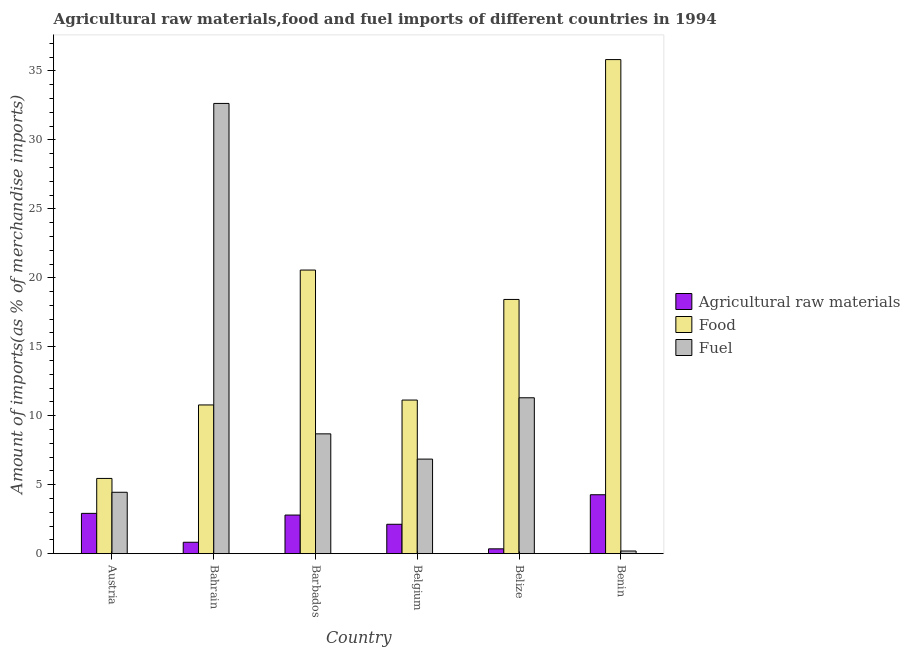How many different coloured bars are there?
Your response must be concise. 3. Are the number of bars on each tick of the X-axis equal?
Offer a very short reply. Yes. How many bars are there on the 1st tick from the left?
Give a very brief answer. 3. In how many cases, is the number of bars for a given country not equal to the number of legend labels?
Provide a short and direct response. 0. What is the percentage of raw materials imports in Austria?
Provide a short and direct response. 2.92. Across all countries, what is the maximum percentage of fuel imports?
Offer a terse response. 32.64. Across all countries, what is the minimum percentage of fuel imports?
Offer a terse response. 0.19. In which country was the percentage of fuel imports maximum?
Make the answer very short. Bahrain. What is the total percentage of raw materials imports in the graph?
Keep it short and to the point. 13.29. What is the difference between the percentage of fuel imports in Barbados and that in Belize?
Make the answer very short. -2.62. What is the difference between the percentage of raw materials imports in Belize and the percentage of food imports in Barbados?
Offer a very short reply. -20.21. What is the average percentage of fuel imports per country?
Offer a terse response. 10.69. What is the difference between the percentage of raw materials imports and percentage of food imports in Belgium?
Your answer should be compact. -9.01. What is the ratio of the percentage of fuel imports in Belgium to that in Benin?
Offer a terse response. 35.95. Is the percentage of food imports in Barbados less than that in Belize?
Offer a terse response. No. Is the difference between the percentage of fuel imports in Bahrain and Belgium greater than the difference between the percentage of food imports in Bahrain and Belgium?
Ensure brevity in your answer.  Yes. What is the difference between the highest and the second highest percentage of raw materials imports?
Offer a very short reply. 1.35. What is the difference between the highest and the lowest percentage of fuel imports?
Make the answer very short. 32.45. In how many countries, is the percentage of fuel imports greater than the average percentage of fuel imports taken over all countries?
Provide a succinct answer. 2. Is the sum of the percentage of fuel imports in Barbados and Belgium greater than the maximum percentage of raw materials imports across all countries?
Your answer should be very brief. Yes. What does the 3rd bar from the left in Austria represents?
Offer a very short reply. Fuel. What does the 3rd bar from the right in Benin represents?
Your response must be concise. Agricultural raw materials. Is it the case that in every country, the sum of the percentage of raw materials imports and percentage of food imports is greater than the percentage of fuel imports?
Make the answer very short. No. What is the difference between two consecutive major ticks on the Y-axis?
Ensure brevity in your answer.  5. Are the values on the major ticks of Y-axis written in scientific E-notation?
Offer a very short reply. No. How many legend labels are there?
Give a very brief answer. 3. How are the legend labels stacked?
Provide a succinct answer. Vertical. What is the title of the graph?
Provide a succinct answer. Agricultural raw materials,food and fuel imports of different countries in 1994. What is the label or title of the X-axis?
Make the answer very short. Country. What is the label or title of the Y-axis?
Provide a short and direct response. Amount of imports(as % of merchandise imports). What is the Amount of imports(as % of merchandise imports) of Agricultural raw materials in Austria?
Provide a short and direct response. 2.92. What is the Amount of imports(as % of merchandise imports) of Food in Austria?
Your answer should be very brief. 5.45. What is the Amount of imports(as % of merchandise imports) of Fuel in Austria?
Your answer should be very brief. 4.45. What is the Amount of imports(as % of merchandise imports) in Agricultural raw materials in Bahrain?
Your answer should be very brief. 0.83. What is the Amount of imports(as % of merchandise imports) in Food in Bahrain?
Your answer should be compact. 10.78. What is the Amount of imports(as % of merchandise imports) of Fuel in Bahrain?
Your answer should be compact. 32.64. What is the Amount of imports(as % of merchandise imports) in Agricultural raw materials in Barbados?
Make the answer very short. 2.8. What is the Amount of imports(as % of merchandise imports) of Food in Barbados?
Keep it short and to the point. 20.56. What is the Amount of imports(as % of merchandise imports) of Fuel in Barbados?
Offer a terse response. 8.69. What is the Amount of imports(as % of merchandise imports) in Agricultural raw materials in Belgium?
Offer a very short reply. 2.13. What is the Amount of imports(as % of merchandise imports) in Food in Belgium?
Offer a very short reply. 11.14. What is the Amount of imports(as % of merchandise imports) of Fuel in Belgium?
Your answer should be very brief. 6.85. What is the Amount of imports(as % of merchandise imports) in Agricultural raw materials in Belize?
Make the answer very short. 0.35. What is the Amount of imports(as % of merchandise imports) in Food in Belize?
Ensure brevity in your answer.  18.43. What is the Amount of imports(as % of merchandise imports) in Fuel in Belize?
Your answer should be compact. 11.3. What is the Amount of imports(as % of merchandise imports) of Agricultural raw materials in Benin?
Your response must be concise. 4.27. What is the Amount of imports(as % of merchandise imports) of Food in Benin?
Give a very brief answer. 35.82. What is the Amount of imports(as % of merchandise imports) in Fuel in Benin?
Offer a terse response. 0.19. Across all countries, what is the maximum Amount of imports(as % of merchandise imports) in Agricultural raw materials?
Offer a very short reply. 4.27. Across all countries, what is the maximum Amount of imports(as % of merchandise imports) of Food?
Your response must be concise. 35.82. Across all countries, what is the maximum Amount of imports(as % of merchandise imports) of Fuel?
Your answer should be compact. 32.64. Across all countries, what is the minimum Amount of imports(as % of merchandise imports) in Agricultural raw materials?
Give a very brief answer. 0.35. Across all countries, what is the minimum Amount of imports(as % of merchandise imports) of Food?
Provide a succinct answer. 5.45. Across all countries, what is the minimum Amount of imports(as % of merchandise imports) of Fuel?
Your answer should be very brief. 0.19. What is the total Amount of imports(as % of merchandise imports) of Agricultural raw materials in the graph?
Your answer should be compact. 13.29. What is the total Amount of imports(as % of merchandise imports) in Food in the graph?
Offer a very short reply. 102.19. What is the total Amount of imports(as % of merchandise imports) in Fuel in the graph?
Ensure brevity in your answer.  64.12. What is the difference between the Amount of imports(as % of merchandise imports) of Agricultural raw materials in Austria and that in Bahrain?
Your answer should be compact. 2.09. What is the difference between the Amount of imports(as % of merchandise imports) in Food in Austria and that in Bahrain?
Your response must be concise. -5.33. What is the difference between the Amount of imports(as % of merchandise imports) of Fuel in Austria and that in Bahrain?
Keep it short and to the point. -28.19. What is the difference between the Amount of imports(as % of merchandise imports) of Agricultural raw materials in Austria and that in Barbados?
Make the answer very short. 0.12. What is the difference between the Amount of imports(as % of merchandise imports) in Food in Austria and that in Barbados?
Ensure brevity in your answer.  -15.11. What is the difference between the Amount of imports(as % of merchandise imports) of Fuel in Austria and that in Barbados?
Offer a terse response. -4.24. What is the difference between the Amount of imports(as % of merchandise imports) of Agricultural raw materials in Austria and that in Belgium?
Offer a very short reply. 0.79. What is the difference between the Amount of imports(as % of merchandise imports) of Food in Austria and that in Belgium?
Provide a short and direct response. -5.68. What is the difference between the Amount of imports(as % of merchandise imports) of Fuel in Austria and that in Belgium?
Ensure brevity in your answer.  -2.4. What is the difference between the Amount of imports(as % of merchandise imports) in Agricultural raw materials in Austria and that in Belize?
Keep it short and to the point. 2.57. What is the difference between the Amount of imports(as % of merchandise imports) in Food in Austria and that in Belize?
Make the answer very short. -12.98. What is the difference between the Amount of imports(as % of merchandise imports) in Fuel in Austria and that in Belize?
Offer a very short reply. -6.85. What is the difference between the Amount of imports(as % of merchandise imports) in Agricultural raw materials in Austria and that in Benin?
Your response must be concise. -1.35. What is the difference between the Amount of imports(as % of merchandise imports) of Food in Austria and that in Benin?
Provide a short and direct response. -30.37. What is the difference between the Amount of imports(as % of merchandise imports) in Fuel in Austria and that in Benin?
Provide a short and direct response. 4.26. What is the difference between the Amount of imports(as % of merchandise imports) in Agricultural raw materials in Bahrain and that in Barbados?
Provide a short and direct response. -1.97. What is the difference between the Amount of imports(as % of merchandise imports) in Food in Bahrain and that in Barbados?
Give a very brief answer. -9.78. What is the difference between the Amount of imports(as % of merchandise imports) in Fuel in Bahrain and that in Barbados?
Provide a short and direct response. 23.96. What is the difference between the Amount of imports(as % of merchandise imports) in Agricultural raw materials in Bahrain and that in Belgium?
Keep it short and to the point. -1.3. What is the difference between the Amount of imports(as % of merchandise imports) in Food in Bahrain and that in Belgium?
Ensure brevity in your answer.  -0.35. What is the difference between the Amount of imports(as % of merchandise imports) in Fuel in Bahrain and that in Belgium?
Keep it short and to the point. 25.79. What is the difference between the Amount of imports(as % of merchandise imports) of Agricultural raw materials in Bahrain and that in Belize?
Your response must be concise. 0.48. What is the difference between the Amount of imports(as % of merchandise imports) in Food in Bahrain and that in Belize?
Make the answer very short. -7.65. What is the difference between the Amount of imports(as % of merchandise imports) of Fuel in Bahrain and that in Belize?
Make the answer very short. 21.34. What is the difference between the Amount of imports(as % of merchandise imports) of Agricultural raw materials in Bahrain and that in Benin?
Your answer should be compact. -3.45. What is the difference between the Amount of imports(as % of merchandise imports) in Food in Bahrain and that in Benin?
Your answer should be compact. -25.04. What is the difference between the Amount of imports(as % of merchandise imports) of Fuel in Bahrain and that in Benin?
Your response must be concise. 32.45. What is the difference between the Amount of imports(as % of merchandise imports) in Agricultural raw materials in Barbados and that in Belgium?
Offer a terse response. 0.67. What is the difference between the Amount of imports(as % of merchandise imports) of Food in Barbados and that in Belgium?
Offer a terse response. 9.43. What is the difference between the Amount of imports(as % of merchandise imports) in Fuel in Barbados and that in Belgium?
Give a very brief answer. 1.83. What is the difference between the Amount of imports(as % of merchandise imports) of Agricultural raw materials in Barbados and that in Belize?
Your answer should be compact. 2.45. What is the difference between the Amount of imports(as % of merchandise imports) of Food in Barbados and that in Belize?
Offer a very short reply. 2.13. What is the difference between the Amount of imports(as % of merchandise imports) of Fuel in Barbados and that in Belize?
Keep it short and to the point. -2.62. What is the difference between the Amount of imports(as % of merchandise imports) in Agricultural raw materials in Barbados and that in Benin?
Offer a very short reply. -1.47. What is the difference between the Amount of imports(as % of merchandise imports) of Food in Barbados and that in Benin?
Provide a succinct answer. -15.26. What is the difference between the Amount of imports(as % of merchandise imports) of Fuel in Barbados and that in Benin?
Make the answer very short. 8.5. What is the difference between the Amount of imports(as % of merchandise imports) in Agricultural raw materials in Belgium and that in Belize?
Keep it short and to the point. 1.78. What is the difference between the Amount of imports(as % of merchandise imports) of Food in Belgium and that in Belize?
Your response must be concise. -7.29. What is the difference between the Amount of imports(as % of merchandise imports) of Fuel in Belgium and that in Belize?
Give a very brief answer. -4.45. What is the difference between the Amount of imports(as % of merchandise imports) in Agricultural raw materials in Belgium and that in Benin?
Your answer should be very brief. -2.14. What is the difference between the Amount of imports(as % of merchandise imports) in Food in Belgium and that in Benin?
Offer a very short reply. -24.69. What is the difference between the Amount of imports(as % of merchandise imports) in Fuel in Belgium and that in Benin?
Your response must be concise. 6.66. What is the difference between the Amount of imports(as % of merchandise imports) of Agricultural raw materials in Belize and that in Benin?
Provide a short and direct response. -3.92. What is the difference between the Amount of imports(as % of merchandise imports) in Food in Belize and that in Benin?
Provide a succinct answer. -17.39. What is the difference between the Amount of imports(as % of merchandise imports) in Fuel in Belize and that in Benin?
Provide a short and direct response. 11.11. What is the difference between the Amount of imports(as % of merchandise imports) in Agricultural raw materials in Austria and the Amount of imports(as % of merchandise imports) in Food in Bahrain?
Offer a very short reply. -7.86. What is the difference between the Amount of imports(as % of merchandise imports) of Agricultural raw materials in Austria and the Amount of imports(as % of merchandise imports) of Fuel in Bahrain?
Make the answer very short. -29.72. What is the difference between the Amount of imports(as % of merchandise imports) of Food in Austria and the Amount of imports(as % of merchandise imports) of Fuel in Bahrain?
Provide a short and direct response. -27.19. What is the difference between the Amount of imports(as % of merchandise imports) in Agricultural raw materials in Austria and the Amount of imports(as % of merchandise imports) in Food in Barbados?
Your answer should be compact. -17.64. What is the difference between the Amount of imports(as % of merchandise imports) of Agricultural raw materials in Austria and the Amount of imports(as % of merchandise imports) of Fuel in Barbados?
Your answer should be compact. -5.77. What is the difference between the Amount of imports(as % of merchandise imports) in Food in Austria and the Amount of imports(as % of merchandise imports) in Fuel in Barbados?
Give a very brief answer. -3.23. What is the difference between the Amount of imports(as % of merchandise imports) in Agricultural raw materials in Austria and the Amount of imports(as % of merchandise imports) in Food in Belgium?
Keep it short and to the point. -8.22. What is the difference between the Amount of imports(as % of merchandise imports) of Agricultural raw materials in Austria and the Amount of imports(as % of merchandise imports) of Fuel in Belgium?
Give a very brief answer. -3.93. What is the difference between the Amount of imports(as % of merchandise imports) of Food in Austria and the Amount of imports(as % of merchandise imports) of Fuel in Belgium?
Your answer should be compact. -1.4. What is the difference between the Amount of imports(as % of merchandise imports) in Agricultural raw materials in Austria and the Amount of imports(as % of merchandise imports) in Food in Belize?
Your answer should be compact. -15.51. What is the difference between the Amount of imports(as % of merchandise imports) of Agricultural raw materials in Austria and the Amount of imports(as % of merchandise imports) of Fuel in Belize?
Offer a very short reply. -8.38. What is the difference between the Amount of imports(as % of merchandise imports) of Food in Austria and the Amount of imports(as % of merchandise imports) of Fuel in Belize?
Give a very brief answer. -5.85. What is the difference between the Amount of imports(as % of merchandise imports) in Agricultural raw materials in Austria and the Amount of imports(as % of merchandise imports) in Food in Benin?
Provide a succinct answer. -32.9. What is the difference between the Amount of imports(as % of merchandise imports) of Agricultural raw materials in Austria and the Amount of imports(as % of merchandise imports) of Fuel in Benin?
Ensure brevity in your answer.  2.73. What is the difference between the Amount of imports(as % of merchandise imports) in Food in Austria and the Amount of imports(as % of merchandise imports) in Fuel in Benin?
Your answer should be compact. 5.26. What is the difference between the Amount of imports(as % of merchandise imports) in Agricultural raw materials in Bahrain and the Amount of imports(as % of merchandise imports) in Food in Barbados?
Ensure brevity in your answer.  -19.74. What is the difference between the Amount of imports(as % of merchandise imports) in Agricultural raw materials in Bahrain and the Amount of imports(as % of merchandise imports) in Fuel in Barbados?
Give a very brief answer. -7.86. What is the difference between the Amount of imports(as % of merchandise imports) of Food in Bahrain and the Amount of imports(as % of merchandise imports) of Fuel in Barbados?
Your response must be concise. 2.1. What is the difference between the Amount of imports(as % of merchandise imports) in Agricultural raw materials in Bahrain and the Amount of imports(as % of merchandise imports) in Food in Belgium?
Ensure brevity in your answer.  -10.31. What is the difference between the Amount of imports(as % of merchandise imports) in Agricultural raw materials in Bahrain and the Amount of imports(as % of merchandise imports) in Fuel in Belgium?
Your response must be concise. -6.03. What is the difference between the Amount of imports(as % of merchandise imports) in Food in Bahrain and the Amount of imports(as % of merchandise imports) in Fuel in Belgium?
Provide a short and direct response. 3.93. What is the difference between the Amount of imports(as % of merchandise imports) in Agricultural raw materials in Bahrain and the Amount of imports(as % of merchandise imports) in Food in Belize?
Keep it short and to the point. -17.6. What is the difference between the Amount of imports(as % of merchandise imports) in Agricultural raw materials in Bahrain and the Amount of imports(as % of merchandise imports) in Fuel in Belize?
Provide a short and direct response. -10.48. What is the difference between the Amount of imports(as % of merchandise imports) in Food in Bahrain and the Amount of imports(as % of merchandise imports) in Fuel in Belize?
Your answer should be very brief. -0.52. What is the difference between the Amount of imports(as % of merchandise imports) in Agricultural raw materials in Bahrain and the Amount of imports(as % of merchandise imports) in Food in Benin?
Give a very brief answer. -35. What is the difference between the Amount of imports(as % of merchandise imports) of Agricultural raw materials in Bahrain and the Amount of imports(as % of merchandise imports) of Fuel in Benin?
Provide a short and direct response. 0.63. What is the difference between the Amount of imports(as % of merchandise imports) of Food in Bahrain and the Amount of imports(as % of merchandise imports) of Fuel in Benin?
Your response must be concise. 10.59. What is the difference between the Amount of imports(as % of merchandise imports) in Agricultural raw materials in Barbados and the Amount of imports(as % of merchandise imports) in Food in Belgium?
Your answer should be very brief. -8.34. What is the difference between the Amount of imports(as % of merchandise imports) in Agricultural raw materials in Barbados and the Amount of imports(as % of merchandise imports) in Fuel in Belgium?
Keep it short and to the point. -4.06. What is the difference between the Amount of imports(as % of merchandise imports) in Food in Barbados and the Amount of imports(as % of merchandise imports) in Fuel in Belgium?
Your answer should be compact. 13.71. What is the difference between the Amount of imports(as % of merchandise imports) of Agricultural raw materials in Barbados and the Amount of imports(as % of merchandise imports) of Food in Belize?
Provide a succinct answer. -15.63. What is the difference between the Amount of imports(as % of merchandise imports) of Agricultural raw materials in Barbados and the Amount of imports(as % of merchandise imports) of Fuel in Belize?
Provide a short and direct response. -8.5. What is the difference between the Amount of imports(as % of merchandise imports) of Food in Barbados and the Amount of imports(as % of merchandise imports) of Fuel in Belize?
Keep it short and to the point. 9.26. What is the difference between the Amount of imports(as % of merchandise imports) of Agricultural raw materials in Barbados and the Amount of imports(as % of merchandise imports) of Food in Benin?
Provide a short and direct response. -33.02. What is the difference between the Amount of imports(as % of merchandise imports) of Agricultural raw materials in Barbados and the Amount of imports(as % of merchandise imports) of Fuel in Benin?
Keep it short and to the point. 2.61. What is the difference between the Amount of imports(as % of merchandise imports) in Food in Barbados and the Amount of imports(as % of merchandise imports) in Fuel in Benin?
Give a very brief answer. 20.37. What is the difference between the Amount of imports(as % of merchandise imports) in Agricultural raw materials in Belgium and the Amount of imports(as % of merchandise imports) in Food in Belize?
Provide a short and direct response. -16.3. What is the difference between the Amount of imports(as % of merchandise imports) of Agricultural raw materials in Belgium and the Amount of imports(as % of merchandise imports) of Fuel in Belize?
Offer a very short reply. -9.17. What is the difference between the Amount of imports(as % of merchandise imports) of Food in Belgium and the Amount of imports(as % of merchandise imports) of Fuel in Belize?
Keep it short and to the point. -0.17. What is the difference between the Amount of imports(as % of merchandise imports) in Agricultural raw materials in Belgium and the Amount of imports(as % of merchandise imports) in Food in Benin?
Make the answer very short. -33.69. What is the difference between the Amount of imports(as % of merchandise imports) of Agricultural raw materials in Belgium and the Amount of imports(as % of merchandise imports) of Fuel in Benin?
Provide a succinct answer. 1.94. What is the difference between the Amount of imports(as % of merchandise imports) of Food in Belgium and the Amount of imports(as % of merchandise imports) of Fuel in Benin?
Your answer should be compact. 10.94. What is the difference between the Amount of imports(as % of merchandise imports) in Agricultural raw materials in Belize and the Amount of imports(as % of merchandise imports) in Food in Benin?
Give a very brief answer. -35.47. What is the difference between the Amount of imports(as % of merchandise imports) of Agricultural raw materials in Belize and the Amount of imports(as % of merchandise imports) of Fuel in Benin?
Make the answer very short. 0.16. What is the difference between the Amount of imports(as % of merchandise imports) in Food in Belize and the Amount of imports(as % of merchandise imports) in Fuel in Benin?
Your answer should be very brief. 18.24. What is the average Amount of imports(as % of merchandise imports) in Agricultural raw materials per country?
Offer a terse response. 2.22. What is the average Amount of imports(as % of merchandise imports) of Food per country?
Make the answer very short. 17.03. What is the average Amount of imports(as % of merchandise imports) in Fuel per country?
Offer a very short reply. 10.69. What is the difference between the Amount of imports(as % of merchandise imports) in Agricultural raw materials and Amount of imports(as % of merchandise imports) in Food in Austria?
Your answer should be very brief. -2.53. What is the difference between the Amount of imports(as % of merchandise imports) in Agricultural raw materials and Amount of imports(as % of merchandise imports) in Fuel in Austria?
Provide a succinct answer. -1.53. What is the difference between the Amount of imports(as % of merchandise imports) in Food and Amount of imports(as % of merchandise imports) in Fuel in Austria?
Your response must be concise. 1. What is the difference between the Amount of imports(as % of merchandise imports) of Agricultural raw materials and Amount of imports(as % of merchandise imports) of Food in Bahrain?
Your response must be concise. -9.96. What is the difference between the Amount of imports(as % of merchandise imports) in Agricultural raw materials and Amount of imports(as % of merchandise imports) in Fuel in Bahrain?
Give a very brief answer. -31.82. What is the difference between the Amount of imports(as % of merchandise imports) of Food and Amount of imports(as % of merchandise imports) of Fuel in Bahrain?
Offer a very short reply. -21.86. What is the difference between the Amount of imports(as % of merchandise imports) in Agricultural raw materials and Amount of imports(as % of merchandise imports) in Food in Barbados?
Make the answer very short. -17.76. What is the difference between the Amount of imports(as % of merchandise imports) of Agricultural raw materials and Amount of imports(as % of merchandise imports) of Fuel in Barbados?
Keep it short and to the point. -5.89. What is the difference between the Amount of imports(as % of merchandise imports) in Food and Amount of imports(as % of merchandise imports) in Fuel in Barbados?
Make the answer very short. 11.88. What is the difference between the Amount of imports(as % of merchandise imports) in Agricultural raw materials and Amount of imports(as % of merchandise imports) in Food in Belgium?
Give a very brief answer. -9.01. What is the difference between the Amount of imports(as % of merchandise imports) of Agricultural raw materials and Amount of imports(as % of merchandise imports) of Fuel in Belgium?
Your response must be concise. -4.72. What is the difference between the Amount of imports(as % of merchandise imports) of Food and Amount of imports(as % of merchandise imports) of Fuel in Belgium?
Make the answer very short. 4.28. What is the difference between the Amount of imports(as % of merchandise imports) in Agricultural raw materials and Amount of imports(as % of merchandise imports) in Food in Belize?
Give a very brief answer. -18.08. What is the difference between the Amount of imports(as % of merchandise imports) in Agricultural raw materials and Amount of imports(as % of merchandise imports) in Fuel in Belize?
Give a very brief answer. -10.95. What is the difference between the Amount of imports(as % of merchandise imports) of Food and Amount of imports(as % of merchandise imports) of Fuel in Belize?
Provide a succinct answer. 7.13. What is the difference between the Amount of imports(as % of merchandise imports) of Agricultural raw materials and Amount of imports(as % of merchandise imports) of Food in Benin?
Your response must be concise. -31.55. What is the difference between the Amount of imports(as % of merchandise imports) of Agricultural raw materials and Amount of imports(as % of merchandise imports) of Fuel in Benin?
Give a very brief answer. 4.08. What is the difference between the Amount of imports(as % of merchandise imports) in Food and Amount of imports(as % of merchandise imports) in Fuel in Benin?
Give a very brief answer. 35.63. What is the ratio of the Amount of imports(as % of merchandise imports) in Agricultural raw materials in Austria to that in Bahrain?
Offer a very short reply. 3.54. What is the ratio of the Amount of imports(as % of merchandise imports) in Food in Austria to that in Bahrain?
Provide a short and direct response. 0.51. What is the ratio of the Amount of imports(as % of merchandise imports) of Fuel in Austria to that in Bahrain?
Ensure brevity in your answer.  0.14. What is the ratio of the Amount of imports(as % of merchandise imports) of Agricultural raw materials in Austria to that in Barbados?
Provide a succinct answer. 1.04. What is the ratio of the Amount of imports(as % of merchandise imports) in Food in Austria to that in Barbados?
Make the answer very short. 0.27. What is the ratio of the Amount of imports(as % of merchandise imports) in Fuel in Austria to that in Barbados?
Offer a very short reply. 0.51. What is the ratio of the Amount of imports(as % of merchandise imports) of Agricultural raw materials in Austria to that in Belgium?
Your response must be concise. 1.37. What is the ratio of the Amount of imports(as % of merchandise imports) of Food in Austria to that in Belgium?
Give a very brief answer. 0.49. What is the ratio of the Amount of imports(as % of merchandise imports) in Fuel in Austria to that in Belgium?
Ensure brevity in your answer.  0.65. What is the ratio of the Amount of imports(as % of merchandise imports) of Agricultural raw materials in Austria to that in Belize?
Your answer should be very brief. 8.39. What is the ratio of the Amount of imports(as % of merchandise imports) in Food in Austria to that in Belize?
Give a very brief answer. 0.3. What is the ratio of the Amount of imports(as % of merchandise imports) in Fuel in Austria to that in Belize?
Ensure brevity in your answer.  0.39. What is the ratio of the Amount of imports(as % of merchandise imports) of Agricultural raw materials in Austria to that in Benin?
Ensure brevity in your answer.  0.68. What is the ratio of the Amount of imports(as % of merchandise imports) in Food in Austria to that in Benin?
Your response must be concise. 0.15. What is the ratio of the Amount of imports(as % of merchandise imports) in Fuel in Austria to that in Benin?
Your answer should be very brief. 23.34. What is the ratio of the Amount of imports(as % of merchandise imports) in Agricultural raw materials in Bahrain to that in Barbados?
Offer a very short reply. 0.3. What is the ratio of the Amount of imports(as % of merchandise imports) of Food in Bahrain to that in Barbados?
Make the answer very short. 0.52. What is the ratio of the Amount of imports(as % of merchandise imports) of Fuel in Bahrain to that in Barbados?
Offer a terse response. 3.76. What is the ratio of the Amount of imports(as % of merchandise imports) in Agricultural raw materials in Bahrain to that in Belgium?
Your response must be concise. 0.39. What is the ratio of the Amount of imports(as % of merchandise imports) of Food in Bahrain to that in Belgium?
Give a very brief answer. 0.97. What is the ratio of the Amount of imports(as % of merchandise imports) in Fuel in Bahrain to that in Belgium?
Your answer should be very brief. 4.76. What is the ratio of the Amount of imports(as % of merchandise imports) of Agricultural raw materials in Bahrain to that in Belize?
Ensure brevity in your answer.  2.37. What is the ratio of the Amount of imports(as % of merchandise imports) of Food in Bahrain to that in Belize?
Provide a short and direct response. 0.58. What is the ratio of the Amount of imports(as % of merchandise imports) in Fuel in Bahrain to that in Belize?
Offer a terse response. 2.89. What is the ratio of the Amount of imports(as % of merchandise imports) of Agricultural raw materials in Bahrain to that in Benin?
Provide a short and direct response. 0.19. What is the ratio of the Amount of imports(as % of merchandise imports) of Food in Bahrain to that in Benin?
Your answer should be very brief. 0.3. What is the ratio of the Amount of imports(as % of merchandise imports) in Fuel in Bahrain to that in Benin?
Your answer should be compact. 171.22. What is the ratio of the Amount of imports(as % of merchandise imports) in Agricultural raw materials in Barbados to that in Belgium?
Ensure brevity in your answer.  1.31. What is the ratio of the Amount of imports(as % of merchandise imports) in Food in Barbados to that in Belgium?
Offer a very short reply. 1.85. What is the ratio of the Amount of imports(as % of merchandise imports) of Fuel in Barbados to that in Belgium?
Ensure brevity in your answer.  1.27. What is the ratio of the Amount of imports(as % of merchandise imports) of Agricultural raw materials in Barbados to that in Belize?
Give a very brief answer. 8.04. What is the ratio of the Amount of imports(as % of merchandise imports) in Food in Barbados to that in Belize?
Your response must be concise. 1.12. What is the ratio of the Amount of imports(as % of merchandise imports) in Fuel in Barbados to that in Belize?
Provide a succinct answer. 0.77. What is the ratio of the Amount of imports(as % of merchandise imports) of Agricultural raw materials in Barbados to that in Benin?
Provide a succinct answer. 0.66. What is the ratio of the Amount of imports(as % of merchandise imports) of Food in Barbados to that in Benin?
Offer a very short reply. 0.57. What is the ratio of the Amount of imports(as % of merchandise imports) in Fuel in Barbados to that in Benin?
Keep it short and to the point. 45.56. What is the ratio of the Amount of imports(as % of merchandise imports) in Agricultural raw materials in Belgium to that in Belize?
Provide a short and direct response. 6.12. What is the ratio of the Amount of imports(as % of merchandise imports) in Food in Belgium to that in Belize?
Provide a short and direct response. 0.6. What is the ratio of the Amount of imports(as % of merchandise imports) in Fuel in Belgium to that in Belize?
Provide a short and direct response. 0.61. What is the ratio of the Amount of imports(as % of merchandise imports) in Agricultural raw materials in Belgium to that in Benin?
Ensure brevity in your answer.  0.5. What is the ratio of the Amount of imports(as % of merchandise imports) of Food in Belgium to that in Benin?
Your response must be concise. 0.31. What is the ratio of the Amount of imports(as % of merchandise imports) of Fuel in Belgium to that in Benin?
Ensure brevity in your answer.  35.95. What is the ratio of the Amount of imports(as % of merchandise imports) in Agricultural raw materials in Belize to that in Benin?
Your response must be concise. 0.08. What is the ratio of the Amount of imports(as % of merchandise imports) of Food in Belize to that in Benin?
Your answer should be compact. 0.51. What is the ratio of the Amount of imports(as % of merchandise imports) in Fuel in Belize to that in Benin?
Provide a succinct answer. 59.28. What is the difference between the highest and the second highest Amount of imports(as % of merchandise imports) in Agricultural raw materials?
Your answer should be compact. 1.35. What is the difference between the highest and the second highest Amount of imports(as % of merchandise imports) of Food?
Offer a very short reply. 15.26. What is the difference between the highest and the second highest Amount of imports(as % of merchandise imports) of Fuel?
Offer a terse response. 21.34. What is the difference between the highest and the lowest Amount of imports(as % of merchandise imports) in Agricultural raw materials?
Your answer should be very brief. 3.92. What is the difference between the highest and the lowest Amount of imports(as % of merchandise imports) of Food?
Your answer should be very brief. 30.37. What is the difference between the highest and the lowest Amount of imports(as % of merchandise imports) in Fuel?
Offer a terse response. 32.45. 